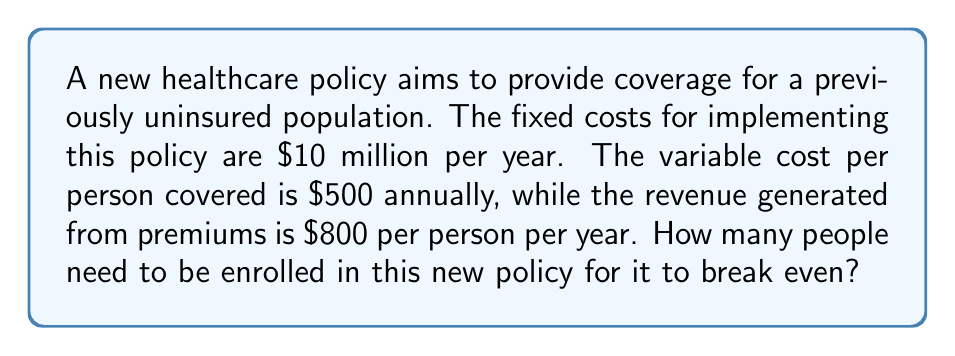Can you answer this question? To determine the break-even point, we need to find the number of people enrolled where total revenue equals total costs.

Let $x$ be the number of people enrolled.

1. Set up the equation:
   Total Revenue = Total Costs
   $800x = 10,000,000 + 500x$

2. Simplify the equation:
   $800x = 10,000,000 + 500x$
   $300x = 10,000,000$

3. Solve for $x$:
   $x = \frac{10,000,000}{300} = 33,333.33$

4. Since we can't have a fractional number of people, we round up to the nearest whole number.

The break-even point is 33,334 people enrolled.

To verify:
Revenue: $800 \times 33,334 = \$26,667,200$
Costs: $10,000,000 + (500 \times 33,334) = \$26,667,000$

The revenue slightly exceeds costs, confirming the break-even point.
Answer: 33,334 people 